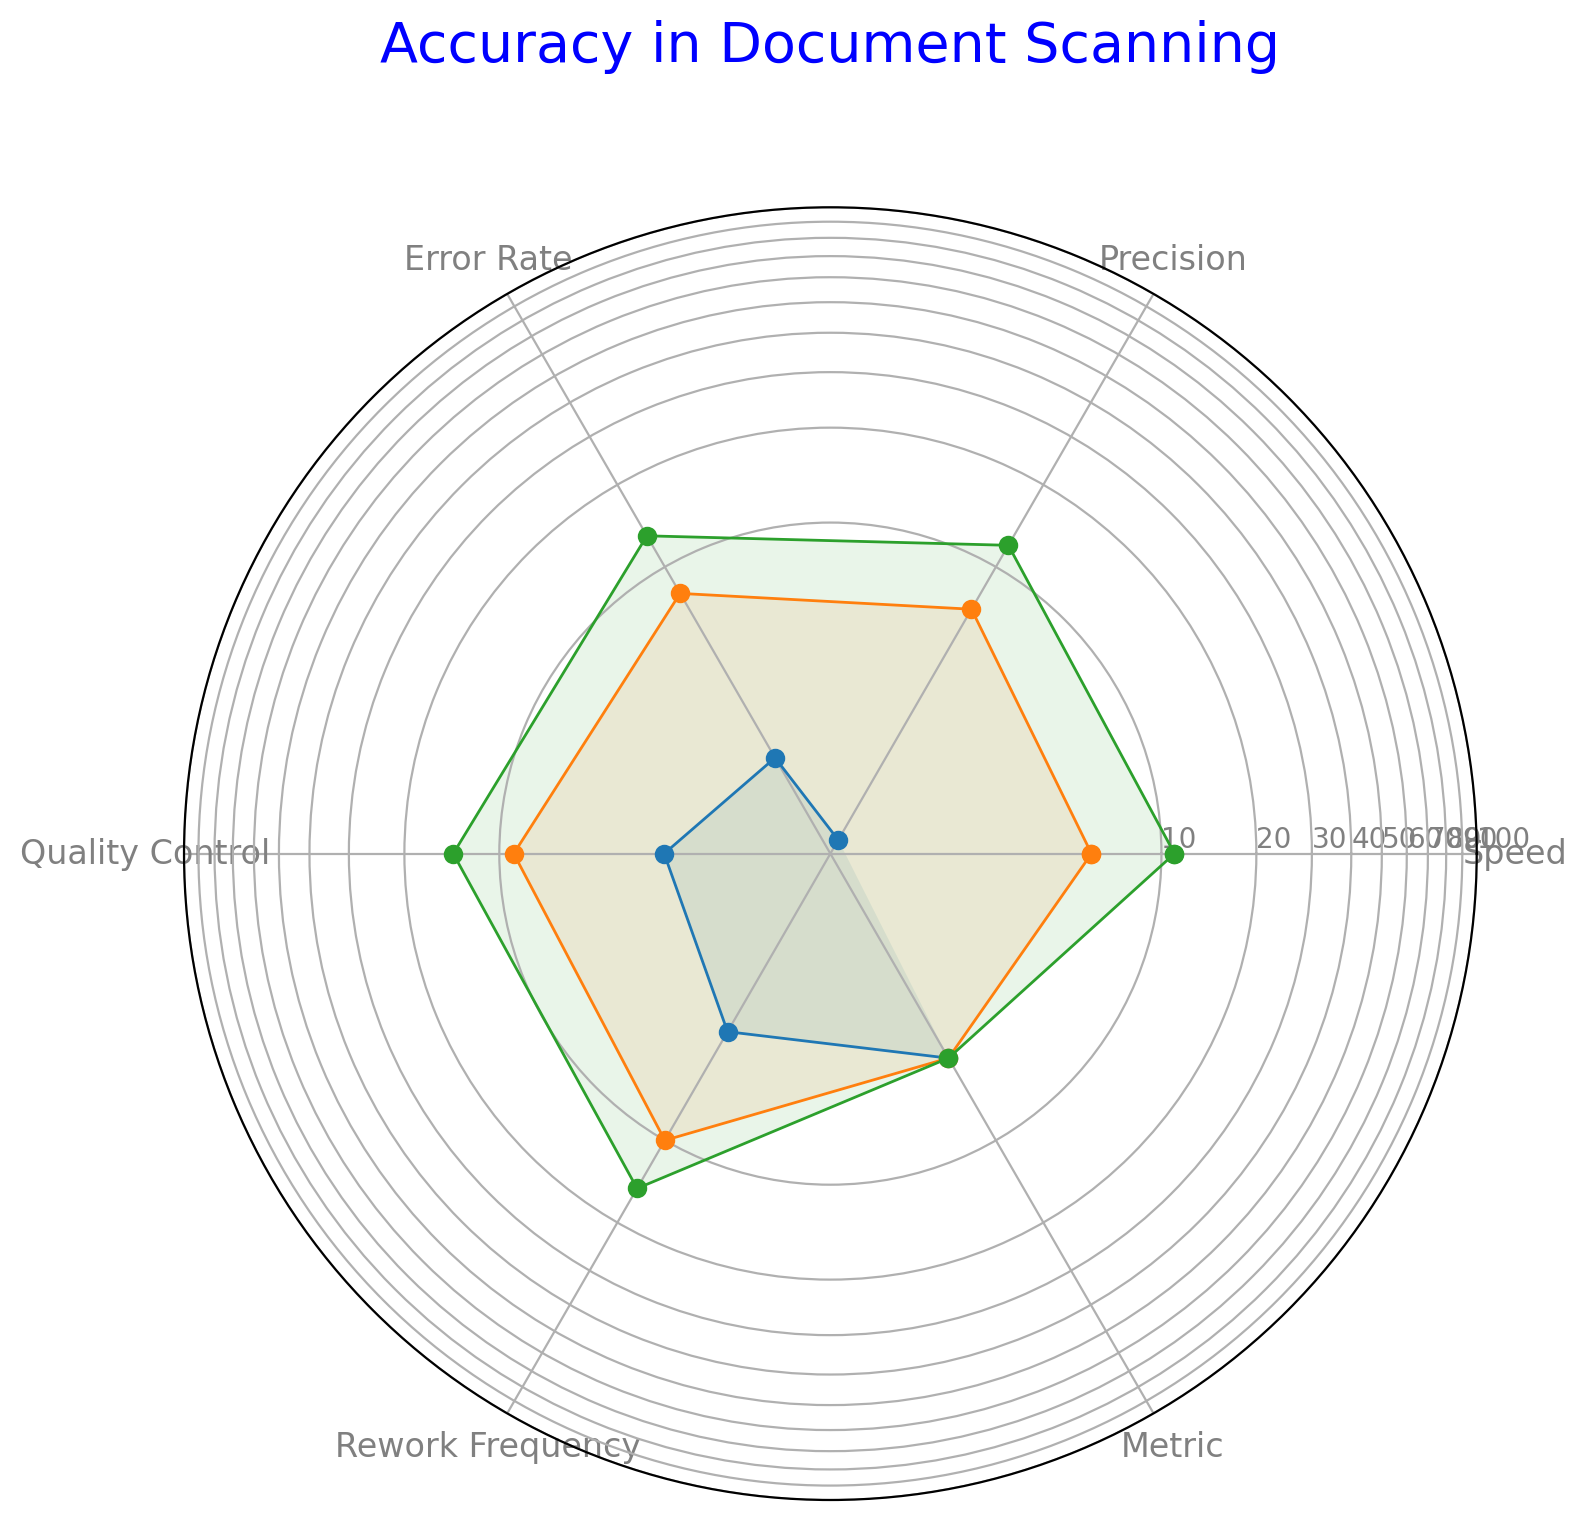Which metric has the highest average value across the entries? To find the highest average value, calculate the average for each metric. Speed's average is (80+78+82+79)/4 = 79.75, Precision's is (90+88+91+89)/4 = 89.5, Error Rate's is (10+12+9+11)/4 = 10.5, Quality Control's is (85+84+87+86)/4 = 85.5, and Rework Frequency's is (15+14+13+16)/4 = 14.5. The highest average is Precision at 89.5.
Answer: Precision Which entry has the fastest Speed? The Speed values are 80, 78, 82, and 79. The fastest Speed is 82 in the third entry.
Answer: Third entry Look at the Error Rates. Which entry has the largest Error Rate? The Error Rates are 10, 12, 9, and 11. The largest Error Rate is 12 in the second entry.
Answer: Second entry What is the difference between the highest and lowest Precision values? The Precision values are 90, 88, 91, and 89. The highest Precision is 91, and the lowest is 88. Thus, the difference is 91 - 88 = 3.
Answer: 3 Comparing the Speed and Precision of each entry, which entry shows the smallest difference between these two metrics? Calculate the differences: First entry (90-80=10), Second (88-78=10), Third (91-82=9), Fourth (89-79=10). The smallest difference is 9 in the third entry.
Answer: Third entry By how much does the highest Quality Control value exceed the lowest? The Quality Control values are 85, 84, 87, and 86. The highest Quality Control is 87, and the lowest is 84. So, the difference is 87 - 84 = 3.
Answer: 3 Which entry has the lowest Rework Frequency? The Rework Frequencies are 15, 14, 13, and 16. The lowest Rework Frequency is 13 in the third entry.
Answer: Third entry If you average the values for all metrics within the first entry, what is the result? Calculate the average: (80+90+10+85+15)/5 = 280/5 = 56.
Answer: 56 Within the first entry, what is the ratio of Quality Control to Error Rate? The Quality Control value is 85, and the Error Rate is 10. The ratio of Quality Control to Error Rate is 85/10 = 8.5.
Answer: 8.5 When considering Quality Control, which entry has consistently higher values compared to the average Quality Control across all entries? The average Quality Control is (85+84+87+86)/4 = 85.5. The values for Quality Control are 85, 84, 87, and 86. Entries with values greater than 85.5 are the third and fourth entries.
Answer: Third and fourth entries 